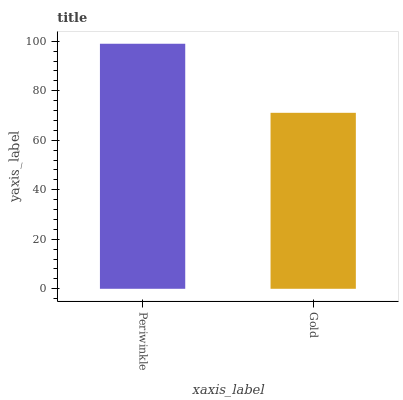Is Gold the minimum?
Answer yes or no. Yes. Is Periwinkle the maximum?
Answer yes or no. Yes. Is Gold the maximum?
Answer yes or no. No. Is Periwinkle greater than Gold?
Answer yes or no. Yes. Is Gold less than Periwinkle?
Answer yes or no. Yes. Is Gold greater than Periwinkle?
Answer yes or no. No. Is Periwinkle less than Gold?
Answer yes or no. No. Is Periwinkle the high median?
Answer yes or no. Yes. Is Gold the low median?
Answer yes or no. Yes. Is Gold the high median?
Answer yes or no. No. Is Periwinkle the low median?
Answer yes or no. No. 